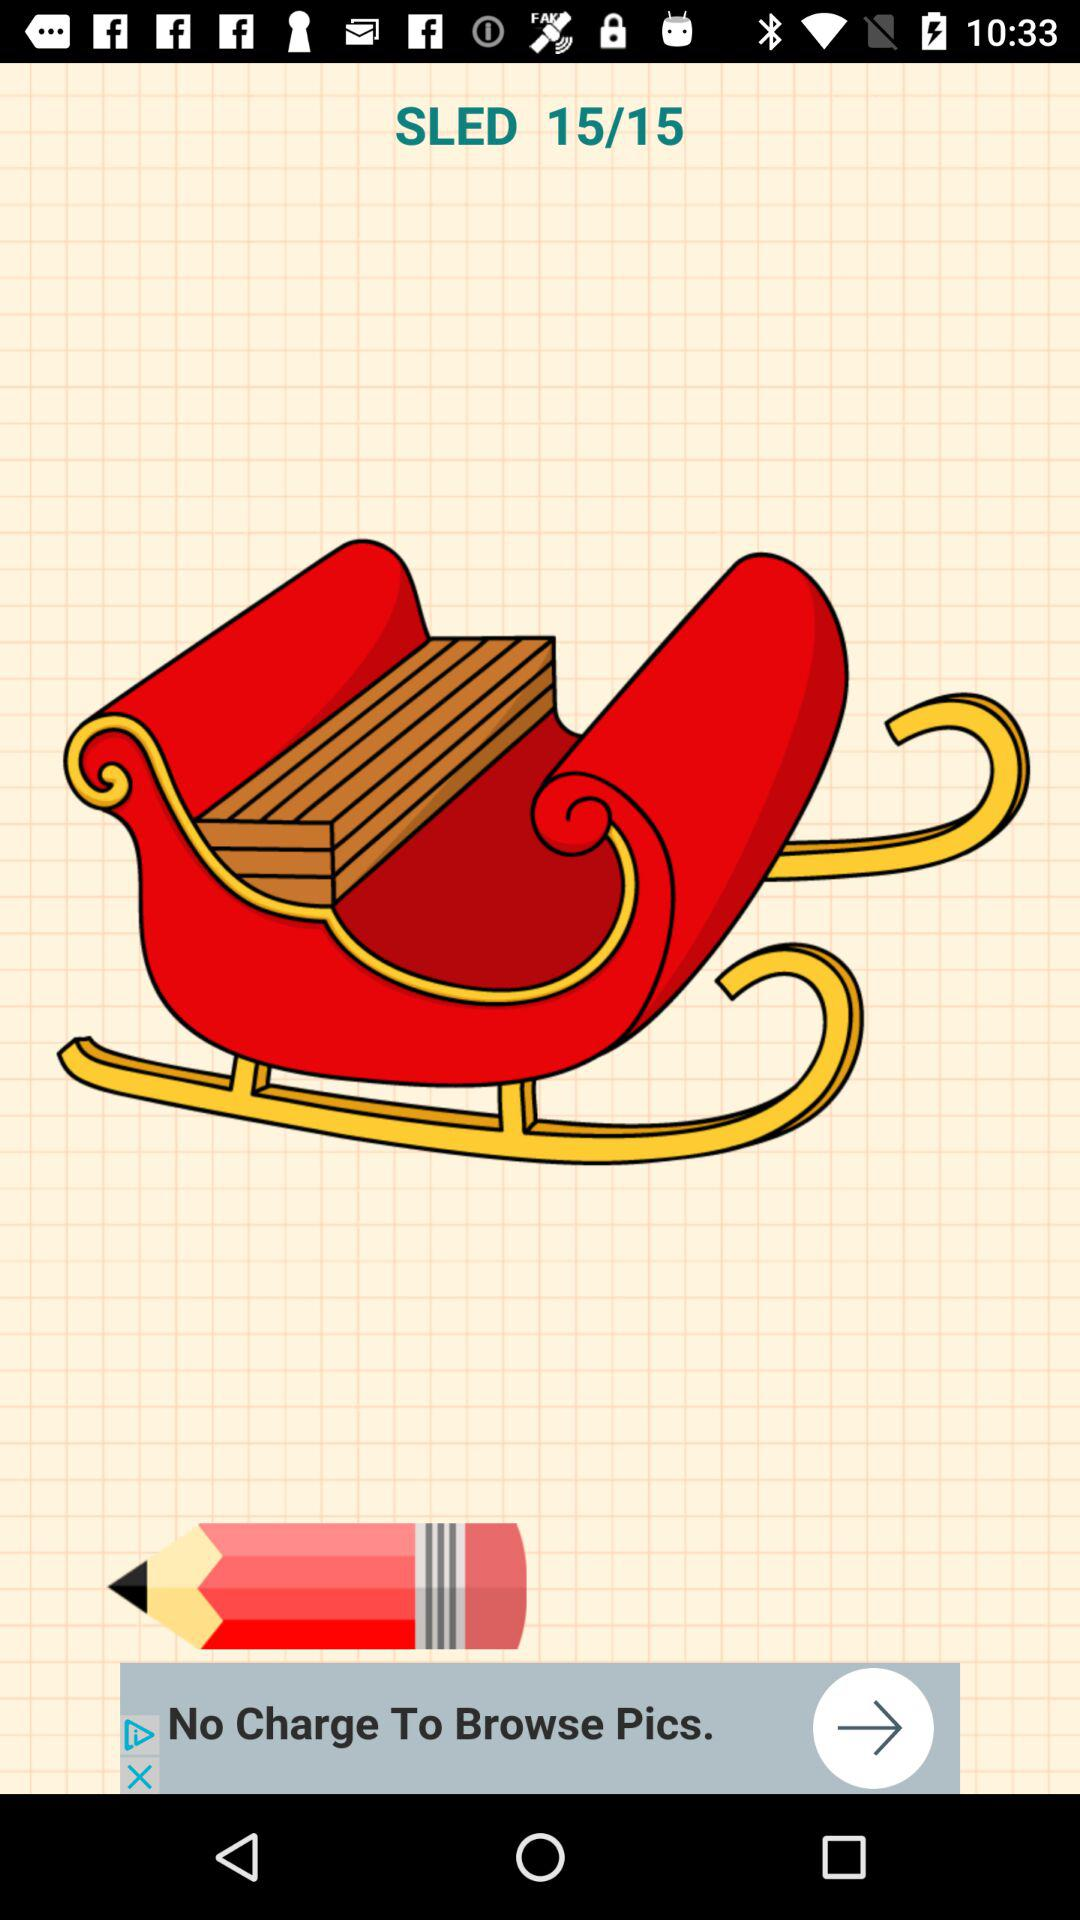At which image am I? You are at image 15. 